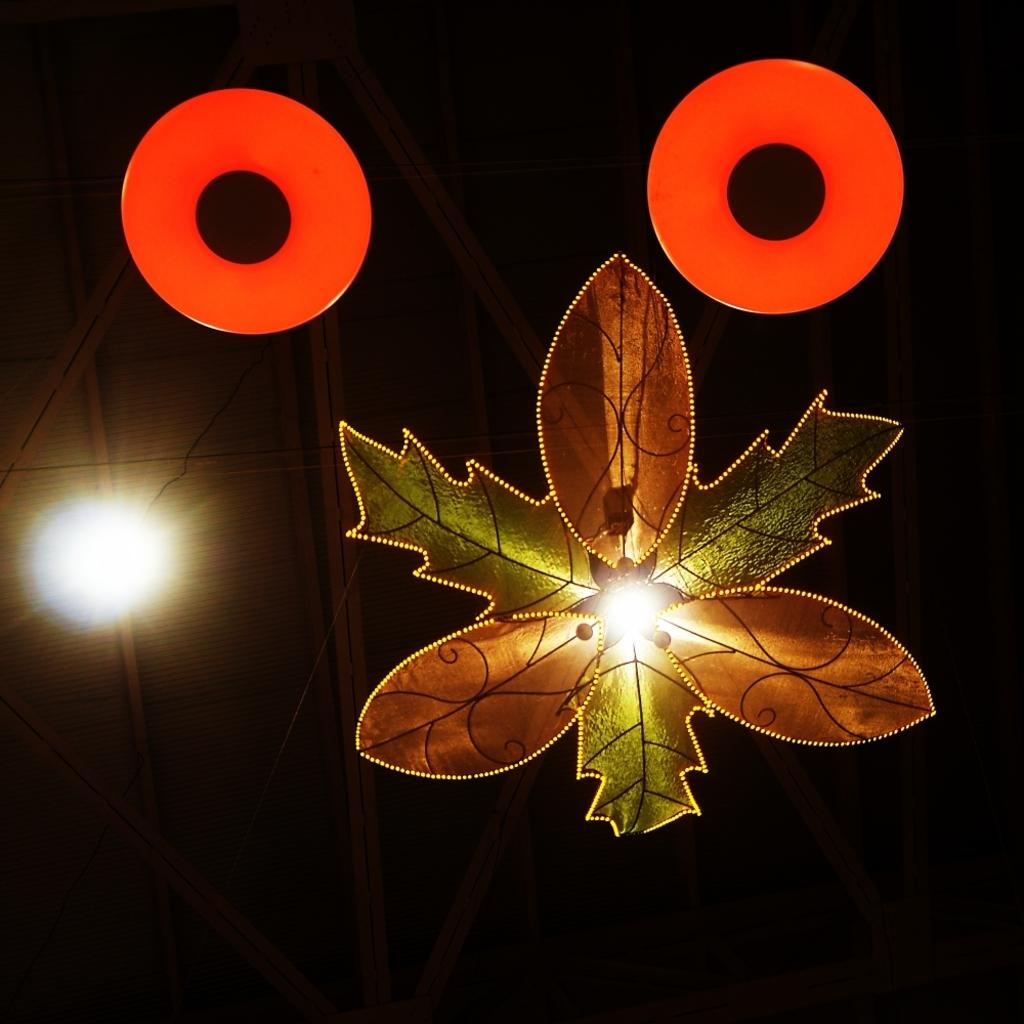What type of ceiling lamp is in the image? There is a leaf-shaped ceiling lamp in the image. What color are the two objects in the image? The two objects in the image are red. Can you describe the lighting in the image? There is light visible in the image. How would you describe the overall appearance of the background in the image? The background of the image is dark. What type of needle is being used for reading in the image? There is no needle or reading activity present in the image. 